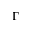<formula> <loc_0><loc_0><loc_500><loc_500>\Gamma</formula> 